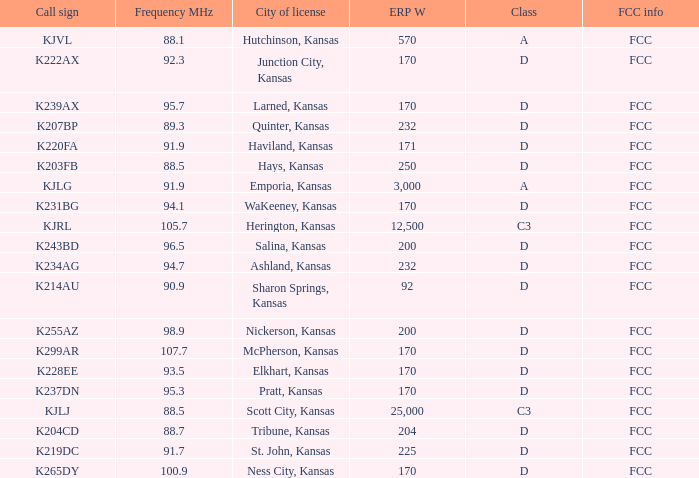Class of d, and a Frequency MHz smaller than 107.7, and a ERP W smaller than 232 has what call sign? K255AZ, K228EE, K220FA, K265DY, K237DN, K214AU, K222AX, K239AX, K243BD, K219DC, K204CD, K231BG. 